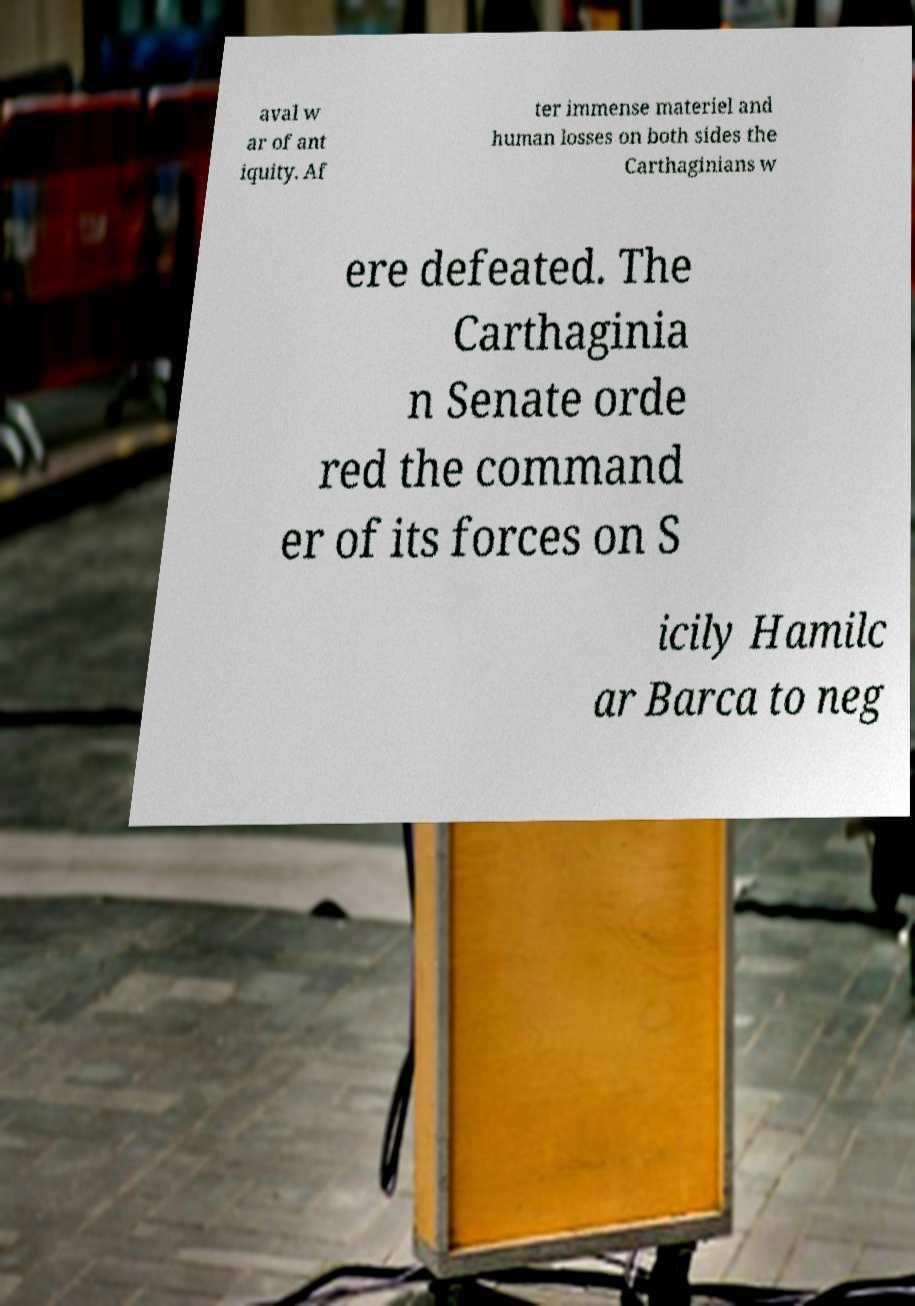There's text embedded in this image that I need extracted. Can you transcribe it verbatim? aval w ar of ant iquity. Af ter immense materiel and human losses on both sides the Carthaginians w ere defeated. The Carthaginia n Senate orde red the command er of its forces on S icily Hamilc ar Barca to neg 